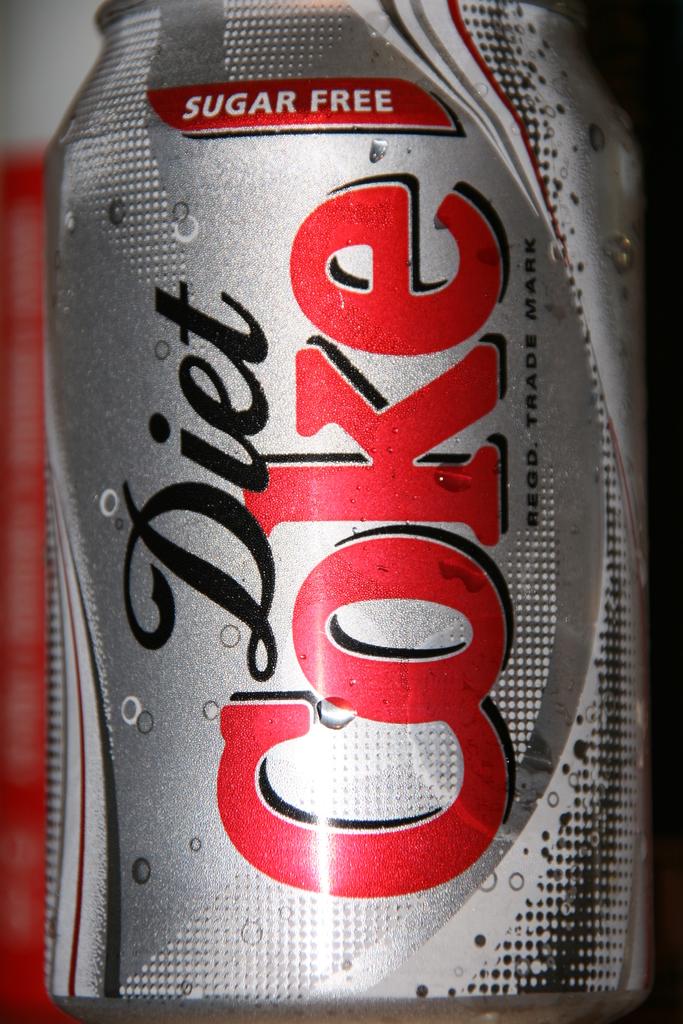Does this contain sugar?
Provide a succinct answer. No. 